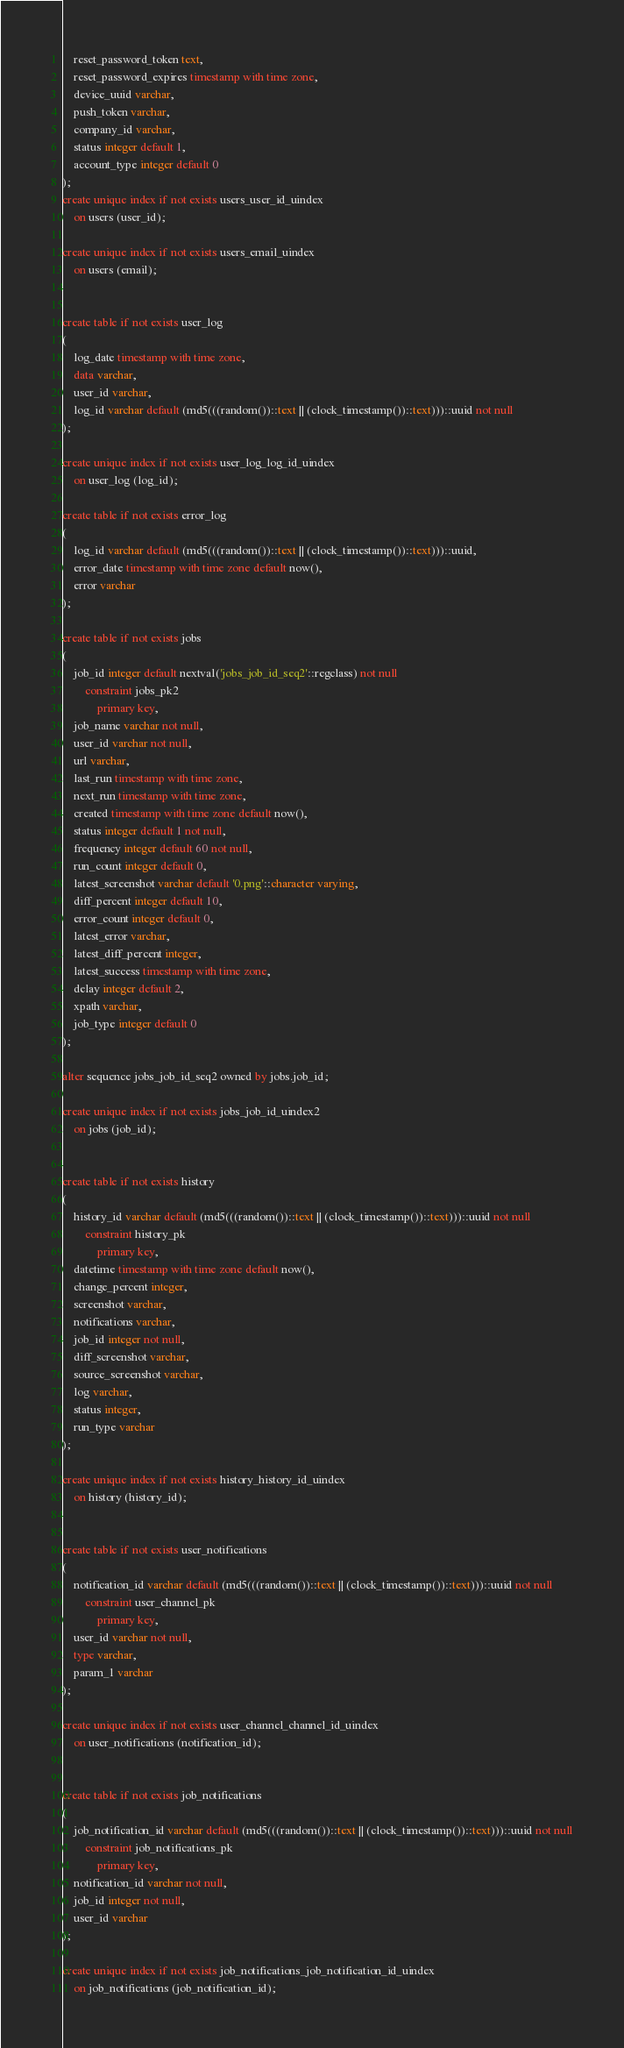<code> <loc_0><loc_0><loc_500><loc_500><_SQL_>	reset_password_token text,
	reset_password_expires timestamp with time zone,
	device_uuid varchar,
	push_token varchar,
	company_id varchar,
	status integer default 1,
	account_type integer default 0
);
create unique index if not exists users_user_id_uindex
	on users (user_id);

create unique index if not exists users_email_uindex
	on users (email);


create table if not exists user_log
(
	log_date timestamp with time zone,
	data varchar,
	user_id varchar,
	log_id varchar default (md5(((random())::text || (clock_timestamp())::text)))::uuid not null
);

create unique index if not exists user_log_log_id_uindex
	on user_log (log_id);

create table if not exists error_log
(
	log_id varchar default (md5(((random())::text || (clock_timestamp())::text)))::uuid,
	error_date timestamp with time zone default now(),
	error varchar
);

create table if not exists jobs
(
	job_id integer default nextval('jobs_job_id_seq2'::regclass) not null
		constraint jobs_pk2
			primary key,
	job_name varchar not null,
	user_id varchar not null,
	url varchar,
	last_run timestamp with time zone,
	next_run timestamp with time zone,
	created timestamp with time zone default now(),
	status integer default 1 not null,
	frequency integer default 60 not null,
	run_count integer default 0,
	latest_screenshot varchar default '0.png'::character varying,
	diff_percent integer default 10,
	error_count integer default 0,
	latest_error varchar,
	latest_diff_percent integer,
	latest_success timestamp with time zone,
	delay integer default 2,
	xpath varchar,
	job_type integer default 0
);

alter sequence jobs_job_id_seq2 owned by jobs.job_id;

create unique index if not exists jobs_job_id_uindex2
	on jobs (job_id);


create table if not exists history
(
	history_id varchar default (md5(((random())::text || (clock_timestamp())::text)))::uuid not null
		constraint history_pk
			primary key,
	datetime timestamp with time zone default now(),
	change_percent integer,
	screenshot varchar,
	notifications varchar,
	job_id integer not null,
	diff_screenshot varchar,
	source_screenshot varchar,
	log varchar,
	status integer,
	run_type varchar
);

create unique index if not exists history_history_id_uindex
	on history (history_id);


create table if not exists user_notifications
(
	notification_id varchar default (md5(((random())::text || (clock_timestamp())::text)))::uuid not null
		constraint user_channel_pk
			primary key,
	user_id varchar not null,
	type varchar,
	param_1 varchar
);

create unique index if not exists user_channel_channel_id_uindex
	on user_notifications (notification_id);


create table if not exists job_notifications
(
	job_notification_id varchar default (md5(((random())::text || (clock_timestamp())::text)))::uuid not null
		constraint job_notifications_pk
			primary key,
	notification_id varchar not null,
	job_id integer not null,
	user_id varchar
);

create unique index if not exists job_notifications_job_notification_id_uindex
	on job_notifications (job_notification_id);</code> 